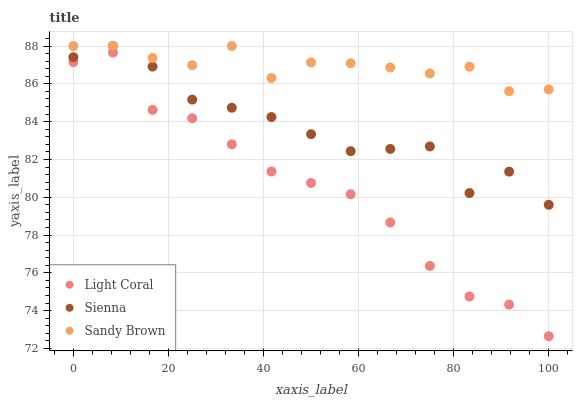Does Light Coral have the minimum area under the curve?
Answer yes or no. Yes. Does Sandy Brown have the maximum area under the curve?
Answer yes or no. Yes. Does Sienna have the minimum area under the curve?
Answer yes or no. No. Does Sienna have the maximum area under the curve?
Answer yes or no. No. Is Sandy Brown the smoothest?
Answer yes or no. Yes. Is Sienna the roughest?
Answer yes or no. Yes. Is Sienna the smoothest?
Answer yes or no. No. Is Sandy Brown the roughest?
Answer yes or no. No. Does Light Coral have the lowest value?
Answer yes or no. Yes. Does Sienna have the lowest value?
Answer yes or no. No. Does Sandy Brown have the highest value?
Answer yes or no. Yes. Is Light Coral less than Sienna?
Answer yes or no. Yes. Is Sienna greater than Light Coral?
Answer yes or no. Yes. Does Sandy Brown intersect Sienna?
Answer yes or no. Yes. Is Sandy Brown less than Sienna?
Answer yes or no. No. Is Sandy Brown greater than Sienna?
Answer yes or no. No. Does Light Coral intersect Sienna?
Answer yes or no. No. 